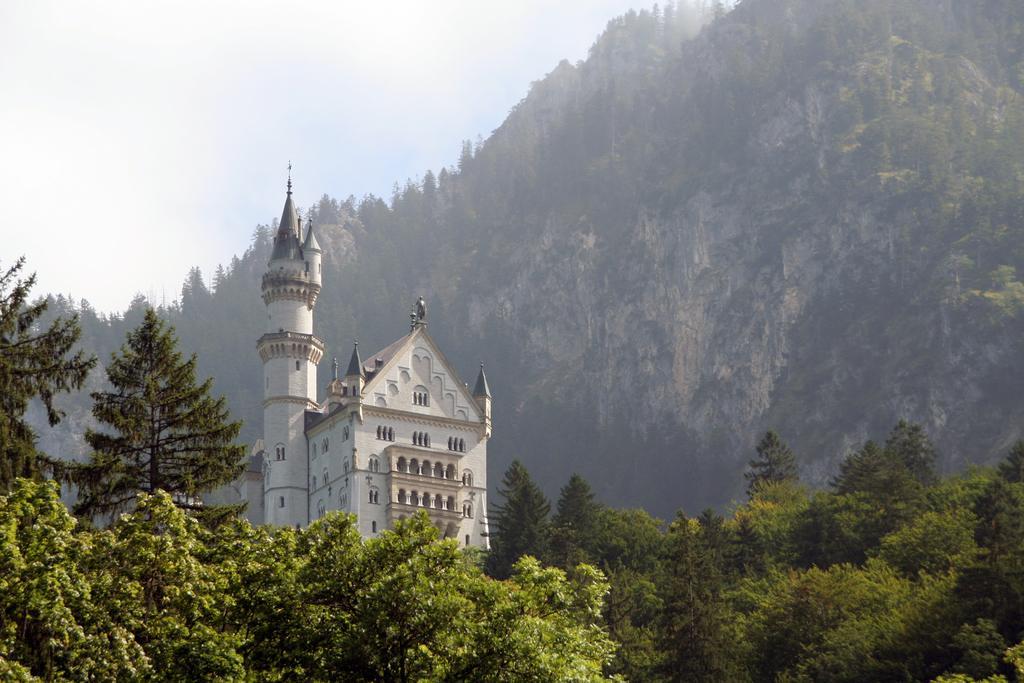Could you give a brief overview of what you see in this image? In this image we can see a building. We can also see a group of trees, the hills and the sky which looks cloudy. 